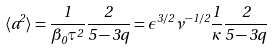<formula> <loc_0><loc_0><loc_500><loc_500>\langle a ^ { 2 } \rangle = \frac { 1 } { \beta _ { 0 } \tau ^ { 2 } } \frac { 2 } { 5 - 3 q } = \epsilon ^ { 3 / 2 } \nu ^ { - 1 / 2 } \frac { 1 } { \kappa } \frac { 2 } { 5 - 3 q }</formula> 